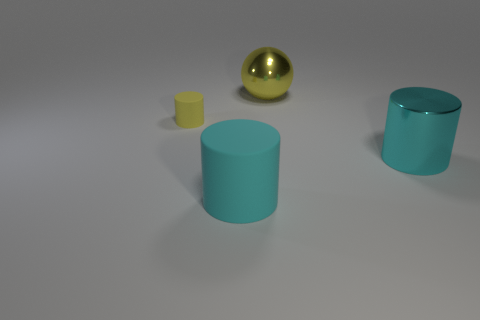Subtract all rubber cylinders. How many cylinders are left? 1 Add 4 matte objects. How many objects exist? 8 Subtract 2 cylinders. How many cylinders are left? 1 Add 2 yellow cylinders. How many yellow cylinders are left? 3 Add 2 matte cylinders. How many matte cylinders exist? 4 Subtract all yellow cylinders. How many cylinders are left? 2 Subtract 0 purple blocks. How many objects are left? 4 Subtract all cylinders. How many objects are left? 1 Subtract all red cylinders. Subtract all yellow spheres. How many cylinders are left? 3 Subtract all green cubes. How many yellow cylinders are left? 1 